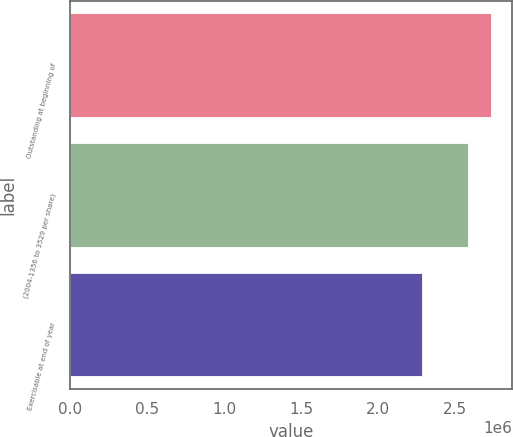Convert chart. <chart><loc_0><loc_0><loc_500><loc_500><bar_chart><fcel>Outstanding at beginning of<fcel>(2004-1356 to 3529 per share)<fcel>Exercisable at end of year<nl><fcel>2.7336e+06<fcel>2.585e+06<fcel>2.2886e+06<nl></chart> 